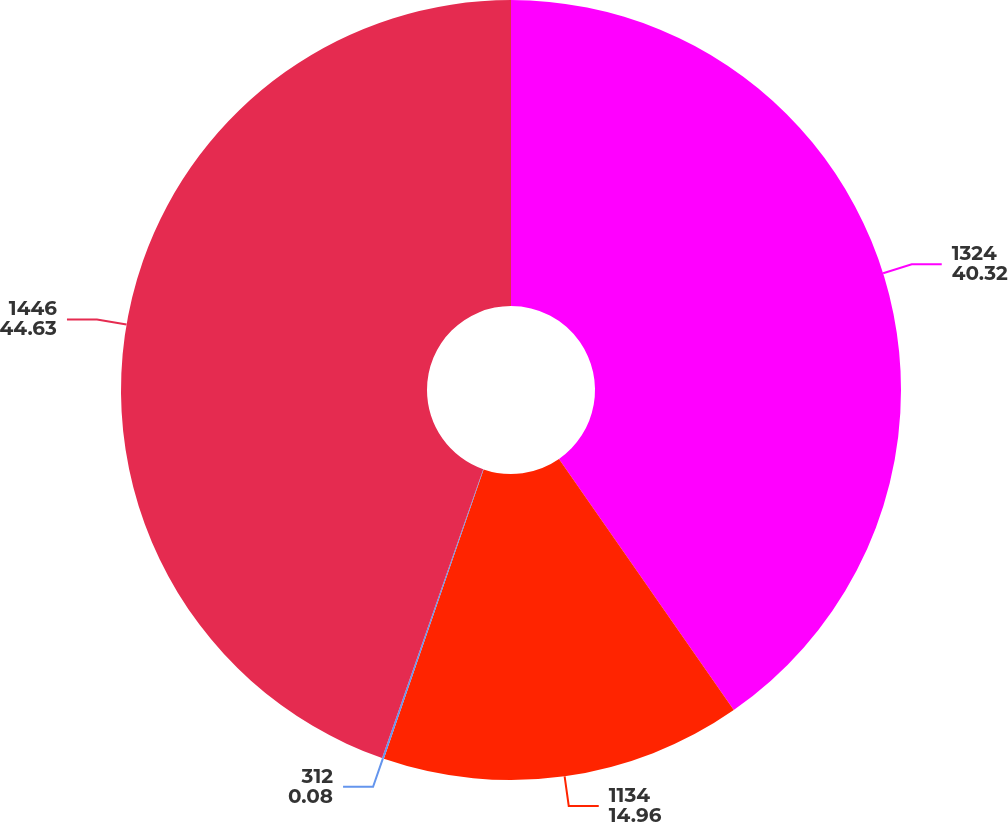Convert chart to OTSL. <chart><loc_0><loc_0><loc_500><loc_500><pie_chart><fcel>1324<fcel>1134<fcel>312<fcel>1446<nl><fcel>40.32%<fcel>14.96%<fcel>0.08%<fcel>44.63%<nl></chart> 